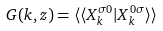Convert formula to latex. <formula><loc_0><loc_0><loc_500><loc_500>G ( k , z ) = \langle \langle X _ { k } ^ { \sigma 0 } | X _ { k } ^ { 0 \sigma } \rangle \rangle</formula> 